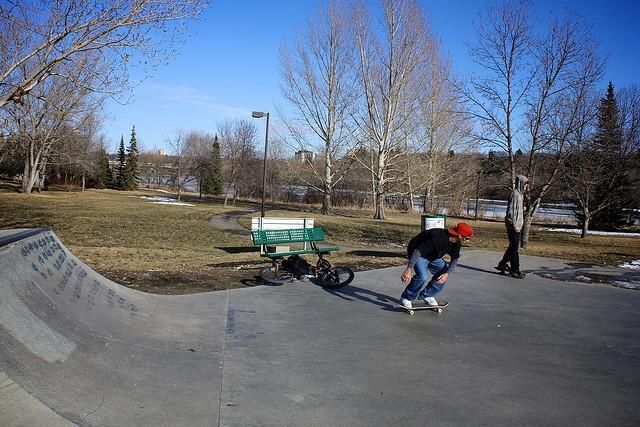How many methods of transportation are seen here?
Give a very brief answer. 2. How many dogs are outside?
Give a very brief answer. 0. 